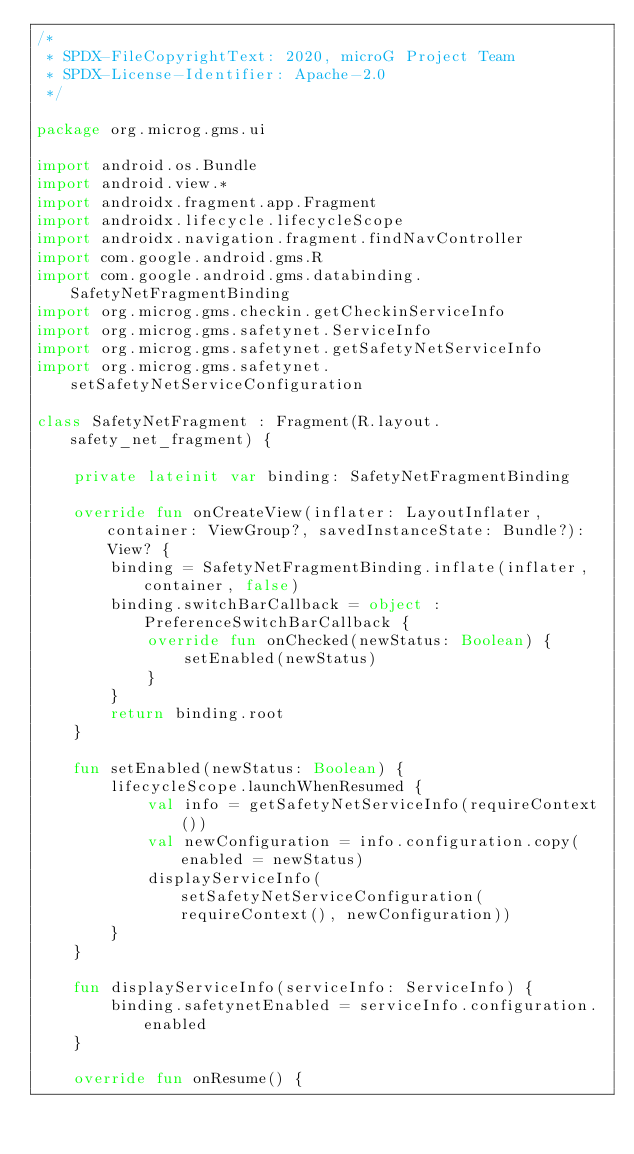<code> <loc_0><loc_0><loc_500><loc_500><_Kotlin_>/*
 * SPDX-FileCopyrightText: 2020, microG Project Team
 * SPDX-License-Identifier: Apache-2.0
 */

package org.microg.gms.ui

import android.os.Bundle
import android.view.*
import androidx.fragment.app.Fragment
import androidx.lifecycle.lifecycleScope
import androidx.navigation.fragment.findNavController
import com.google.android.gms.R
import com.google.android.gms.databinding.SafetyNetFragmentBinding
import org.microg.gms.checkin.getCheckinServiceInfo
import org.microg.gms.safetynet.ServiceInfo
import org.microg.gms.safetynet.getSafetyNetServiceInfo
import org.microg.gms.safetynet.setSafetyNetServiceConfiguration

class SafetyNetFragment : Fragment(R.layout.safety_net_fragment) {

    private lateinit var binding: SafetyNetFragmentBinding

    override fun onCreateView(inflater: LayoutInflater, container: ViewGroup?, savedInstanceState: Bundle?): View? {
        binding = SafetyNetFragmentBinding.inflate(inflater, container, false)
        binding.switchBarCallback = object : PreferenceSwitchBarCallback {
            override fun onChecked(newStatus: Boolean) {
                setEnabled(newStatus)
            }
        }
        return binding.root
    }

    fun setEnabled(newStatus: Boolean) {
        lifecycleScope.launchWhenResumed {
            val info = getSafetyNetServiceInfo(requireContext())
            val newConfiguration = info.configuration.copy(enabled = newStatus)
            displayServiceInfo(setSafetyNetServiceConfiguration(requireContext(), newConfiguration))
        }
    }

    fun displayServiceInfo(serviceInfo: ServiceInfo) {
        binding.safetynetEnabled = serviceInfo.configuration.enabled
    }

    override fun onResume() {</code> 